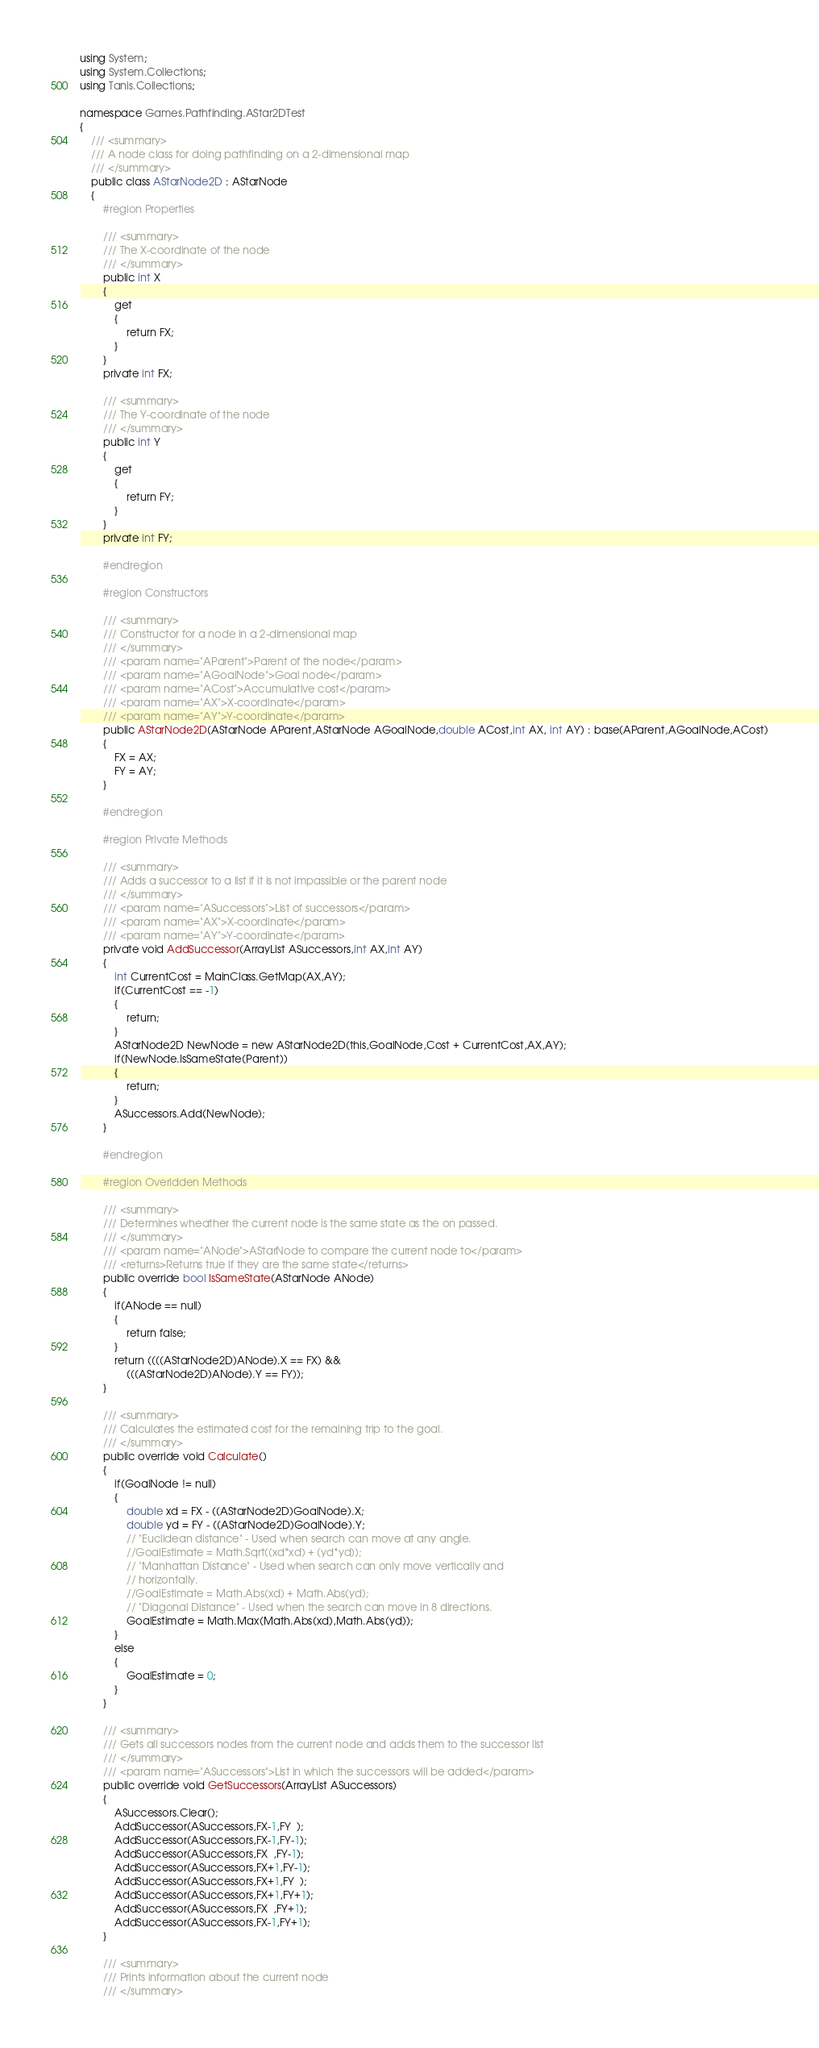<code> <loc_0><loc_0><loc_500><loc_500><_C#_>using System;
using System.Collections;
using Tanis.Collections;

namespace Games.Pathfinding.AStar2DTest
{
	/// <summary>
	/// A node class for doing pathfinding on a 2-dimensional map
	/// </summary>
	public class AStarNode2D : AStarNode
	{
		#region Properties

		/// <summary>
		/// The X-coordinate of the node
		/// </summary>
		public int X 
		{
			get 
			{
				return FX;
			}
		}
		private int FX;

		/// <summary>
		/// The Y-coordinate of the node
		/// </summary>
		public int Y
		{
			get
			{
				return FY;
			}
		}
		private int FY;

		#endregion
	
		#region Constructors

		/// <summary>
		/// Constructor for a node in a 2-dimensional map
		/// </summary>
		/// <param name="AParent">Parent of the node</param>
		/// <param name="AGoalNode">Goal node</param>
		/// <param name="ACost">Accumulative cost</param>
		/// <param name="AX">X-coordinate</param>
		/// <param name="AY">Y-coordinate</param>
		public AStarNode2D(AStarNode AParent,AStarNode AGoalNode,double ACost,int AX, int AY) : base(AParent,AGoalNode,ACost)
		{
			FX = AX;
			FY = AY;
		}

		#endregion

		#region Private Methods

		/// <summary>
		/// Adds a successor to a list if it is not impassible or the parent node
		/// </summary>
		/// <param name="ASuccessors">List of successors</param>
		/// <param name="AX">X-coordinate</param>
		/// <param name="AY">Y-coordinate</param>
		private void AddSuccessor(ArrayList ASuccessors,int AX,int AY) 
		{
			int CurrentCost = MainClass.GetMap(AX,AY);
			if(CurrentCost == -1) 
			{
				return;
			}
			AStarNode2D NewNode = new AStarNode2D(this,GoalNode,Cost + CurrentCost,AX,AY);
			if(NewNode.IsSameState(Parent)) 
			{
				return;
			}
			ASuccessors.Add(NewNode);
		}

		#endregion

		#region Overidden Methods

		/// <summary>
		/// Determines wheather the current node is the same state as the on passed.
		/// </summary>
		/// <param name="ANode">AStarNode to compare the current node to</param>
		/// <returns>Returns true if they are the same state</returns>
		public override bool IsSameState(AStarNode ANode)
		{
			if(ANode == null) 
			{
				return false;
			}
			return ((((AStarNode2D)ANode).X == FX) &&
				(((AStarNode2D)ANode).Y == FY));
		}
		
		/// <summary>
		/// Calculates the estimated cost for the remaining trip to the goal.
		/// </summary>
		public override void Calculate()
		{
			if(GoalNode != null) 
			{
				double xd = FX - ((AStarNode2D)GoalNode).X;
				double yd = FY - ((AStarNode2D)GoalNode).Y;
				// "Euclidean distance" - Used when search can move at any angle.
				//GoalEstimate = Math.Sqrt((xd*xd) + (yd*yd));
				// "Manhattan Distance" - Used when search can only move vertically and 
				// horizontally.
				//GoalEstimate = Math.Abs(xd) + Math.Abs(yd); 
				// "Diagonal Distance" - Used when the search can move in 8 directions.
				GoalEstimate = Math.Max(Math.Abs(xd),Math.Abs(yd));
			}
			else
			{
				GoalEstimate = 0;
			}
		}

		/// <summary>
		/// Gets all successors nodes from the current node and adds them to the successor list
		/// </summary>
		/// <param name="ASuccessors">List in which the successors will be added</param>
		public override void GetSuccessors(ArrayList ASuccessors)
		{
			ASuccessors.Clear();
			AddSuccessor(ASuccessors,FX-1,FY  );
			AddSuccessor(ASuccessors,FX-1,FY-1);
			AddSuccessor(ASuccessors,FX  ,FY-1);
			AddSuccessor(ASuccessors,FX+1,FY-1);
			AddSuccessor(ASuccessors,FX+1,FY  );
			AddSuccessor(ASuccessors,FX+1,FY+1);
			AddSuccessor(ASuccessors,FX  ,FY+1);
			AddSuccessor(ASuccessors,FX-1,FY+1);
		}	

		/// <summary>
		/// Prints information about the current node
		/// </summary></code> 